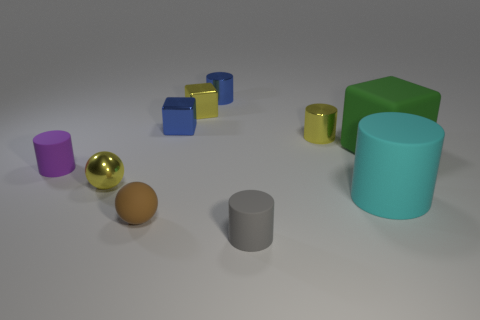Are there any tiny purple matte objects that have the same shape as the small brown thing?
Offer a terse response. No. There is a rubber block; is its size the same as the gray thing that is on the left side of the large cyan matte thing?
Provide a succinct answer. No. What number of objects are either shiny objects that are to the left of the small gray cylinder or rubber objects to the right of the small brown ball?
Ensure brevity in your answer.  7. Are there more objects that are in front of the brown rubber ball than tiny gray cylinders?
Give a very brief answer. No. What number of cubes are the same size as the cyan cylinder?
Ensure brevity in your answer.  1. There is a rubber thing on the left side of the small yellow sphere; is its size the same as the cube that is right of the large cyan rubber cylinder?
Give a very brief answer. No. How big is the cylinder that is in front of the brown matte ball?
Make the answer very short. Small. There is a blue shiny object on the right side of the tiny shiny block to the left of the small yellow metallic block; how big is it?
Keep it short and to the point. Small. There is a brown thing that is the same size as the gray object; what is it made of?
Offer a terse response. Rubber. There is a tiny brown sphere; are there any gray rubber cylinders on the left side of it?
Your response must be concise. No. 